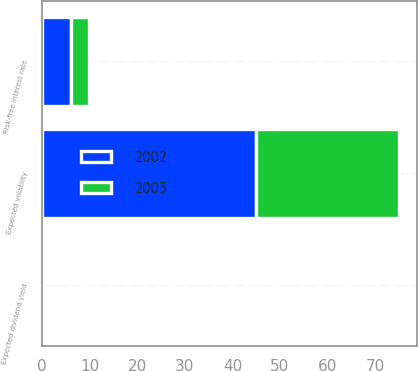<chart> <loc_0><loc_0><loc_500><loc_500><stacked_bar_chart><ecel><fcel>Risk-free interest rate<fcel>Expected volatility<fcel>Expected dividend yield<nl><fcel>2003<fcel>3.84<fcel>30<fcel>0<nl><fcel>2002<fcel>5.95<fcel>45<fcel>0<nl></chart> 